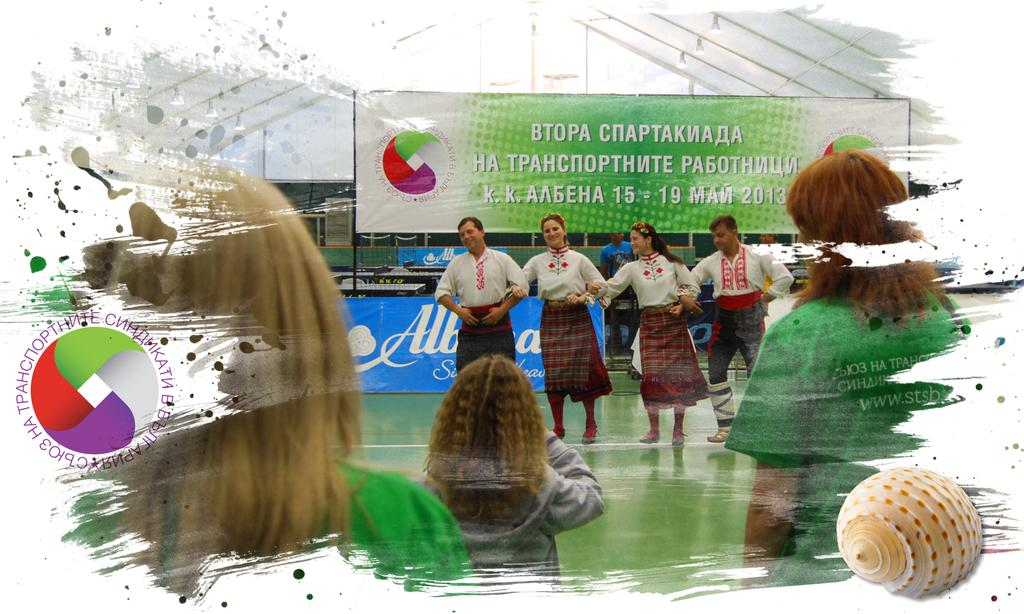What are the people in the picture doing? There are people dancing in the picture. Are there any other people in the picture who are not dancing? Yes, there are people standing in the picture. What can be seen in the background of the picture? There is a poster visible in the background of the picture. What type of box is being used to play the song in the picture? There is no box or song present in the picture; it only shows people dancing and standing. 